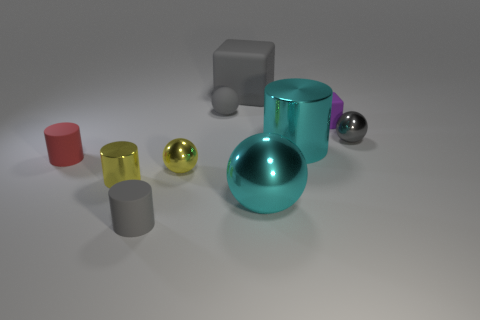Subtract all yellow cubes. How many gray spheres are left? 2 Subtract 1 balls. How many balls are left? 3 Subtract all big cylinders. How many cylinders are left? 3 Subtract all cyan cylinders. How many cylinders are left? 3 Subtract all green balls. Subtract all red cubes. How many balls are left? 4 Subtract all spheres. How many objects are left? 6 Subtract all small yellow metal balls. Subtract all gray shiny balls. How many objects are left? 8 Add 2 cyan metallic spheres. How many cyan metallic spheres are left? 3 Add 4 tiny cyan metal objects. How many tiny cyan metal objects exist? 4 Subtract 0 cyan blocks. How many objects are left? 10 